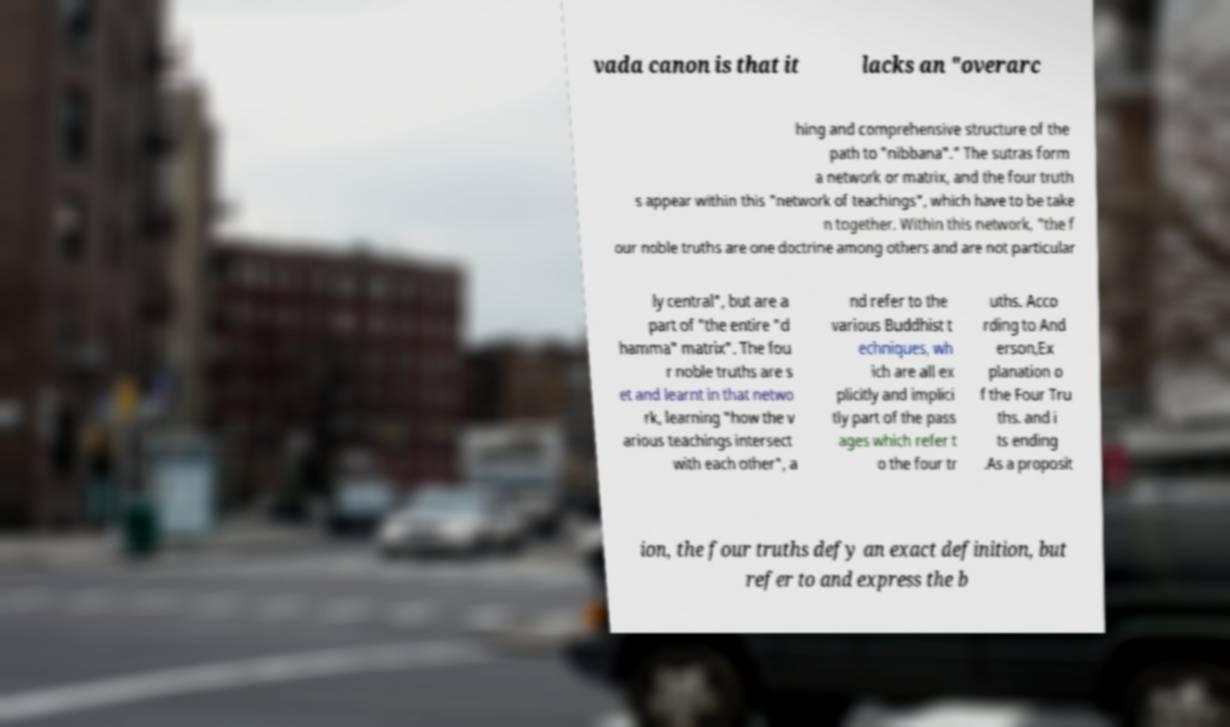What messages or text are displayed in this image? I need them in a readable, typed format. vada canon is that it lacks an "overarc hing and comprehensive structure of the path to "nibbana"." The sutras form a network or matrix, and the four truth s appear within this "network of teachings", which have to be take n together. Within this network, "the f our noble truths are one doctrine among others and are not particular ly central", but are a part of "the entire "d hamma" matrix". The fou r noble truths are s et and learnt in that netwo rk, learning "how the v arious teachings intersect with each other", a nd refer to the various Buddhist t echniques, wh ich are all ex plicitly and implici tly part of the pass ages which refer t o the four tr uths. Acco rding to And erson,Ex planation o f the Four Tru ths. and i ts ending .As a proposit ion, the four truths defy an exact definition, but refer to and express the b 